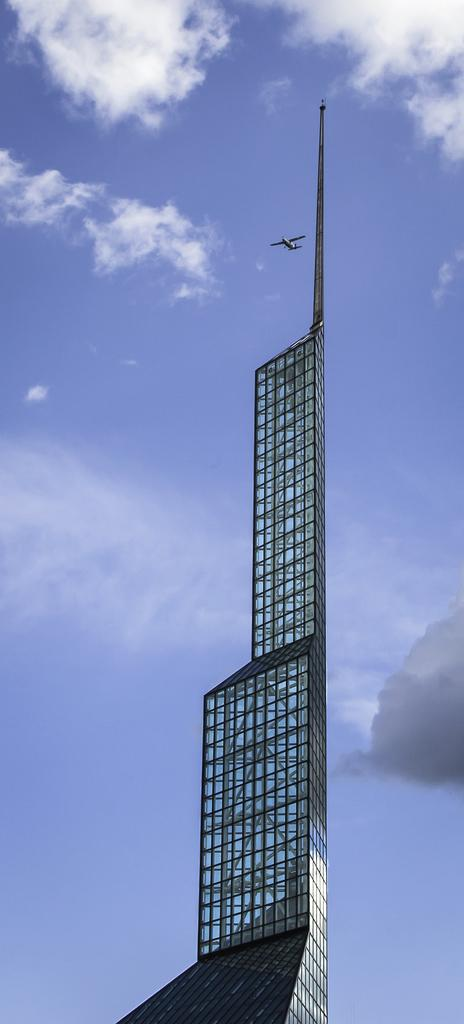What type of structure is visible in the image? There is a high-rise building in the image. What else can be seen in the sky in the image? There is a plane flying in the sky in the image. How many beds are visible in the image? There are no beds present in the image. What type of ice can be seen melting on the high-rise building? There is no ice present in the image. 